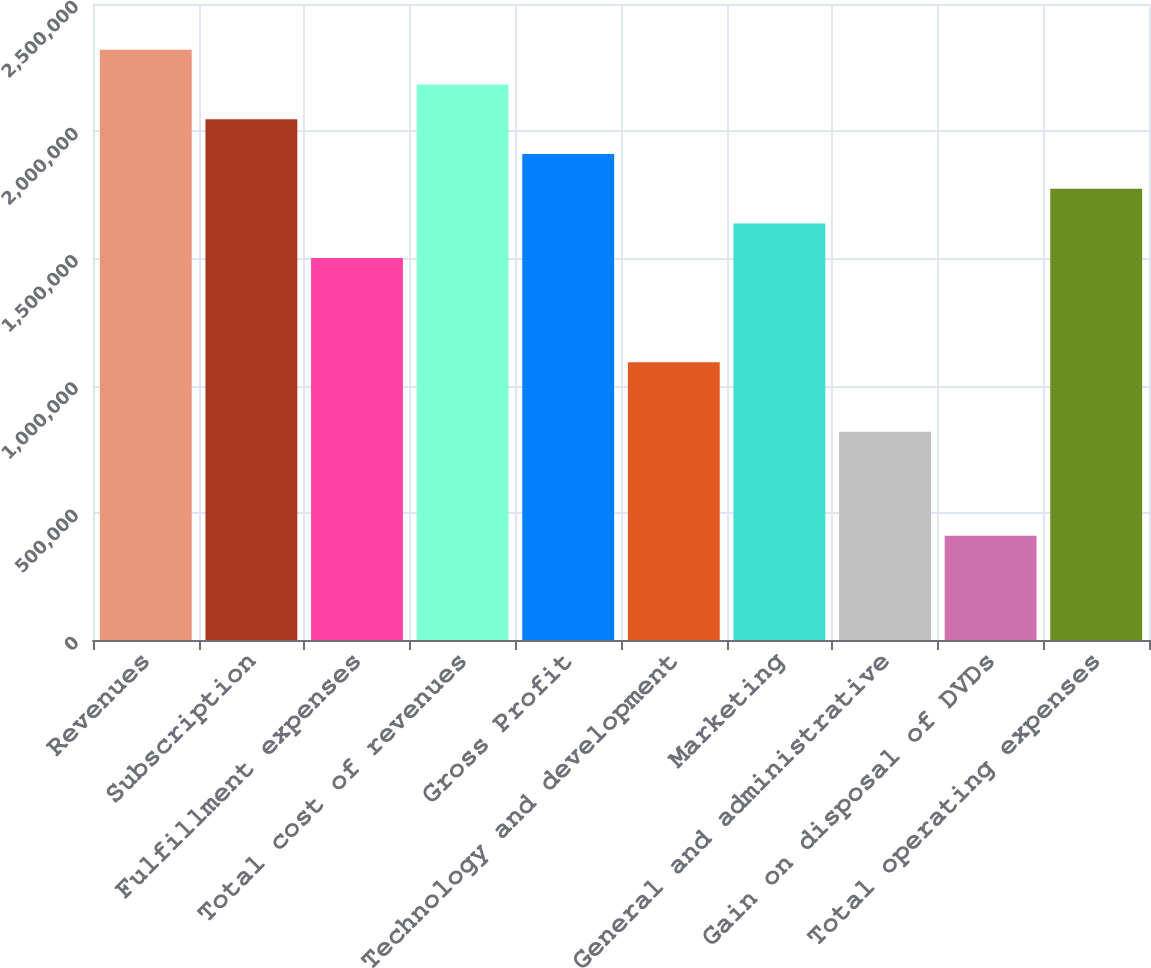<chart> <loc_0><loc_0><loc_500><loc_500><bar_chart><fcel>Revenues<fcel>Subscription<fcel>Fulfillment expenses<fcel>Total cost of revenues<fcel>Gross Profit<fcel>Technology and development<fcel>Marketing<fcel>General and administrative<fcel>Gain on disposal of DVDs<fcel>Total operating expenses<nl><fcel>2.31992e+06<fcel>2.04699e+06<fcel>1.50113e+06<fcel>2.18346e+06<fcel>1.91052e+06<fcel>1.09173e+06<fcel>1.63759e+06<fcel>818797<fcel>409399<fcel>1.77406e+06<nl></chart> 